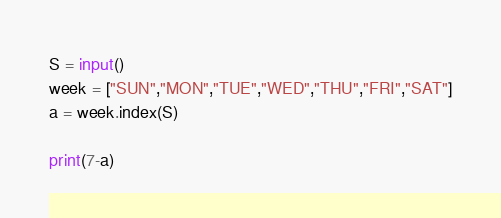<code> <loc_0><loc_0><loc_500><loc_500><_Python_>S = input()
week = ["SUN","MON","TUE","WED","THU","FRI","SAT"]
a = week.index(S)

print(7-a)</code> 